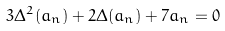<formula> <loc_0><loc_0><loc_500><loc_500>3 \Delta ^ { 2 } ( a _ { n } ) + 2 \Delta ( a _ { n } ) + 7 a _ { n } = 0</formula> 